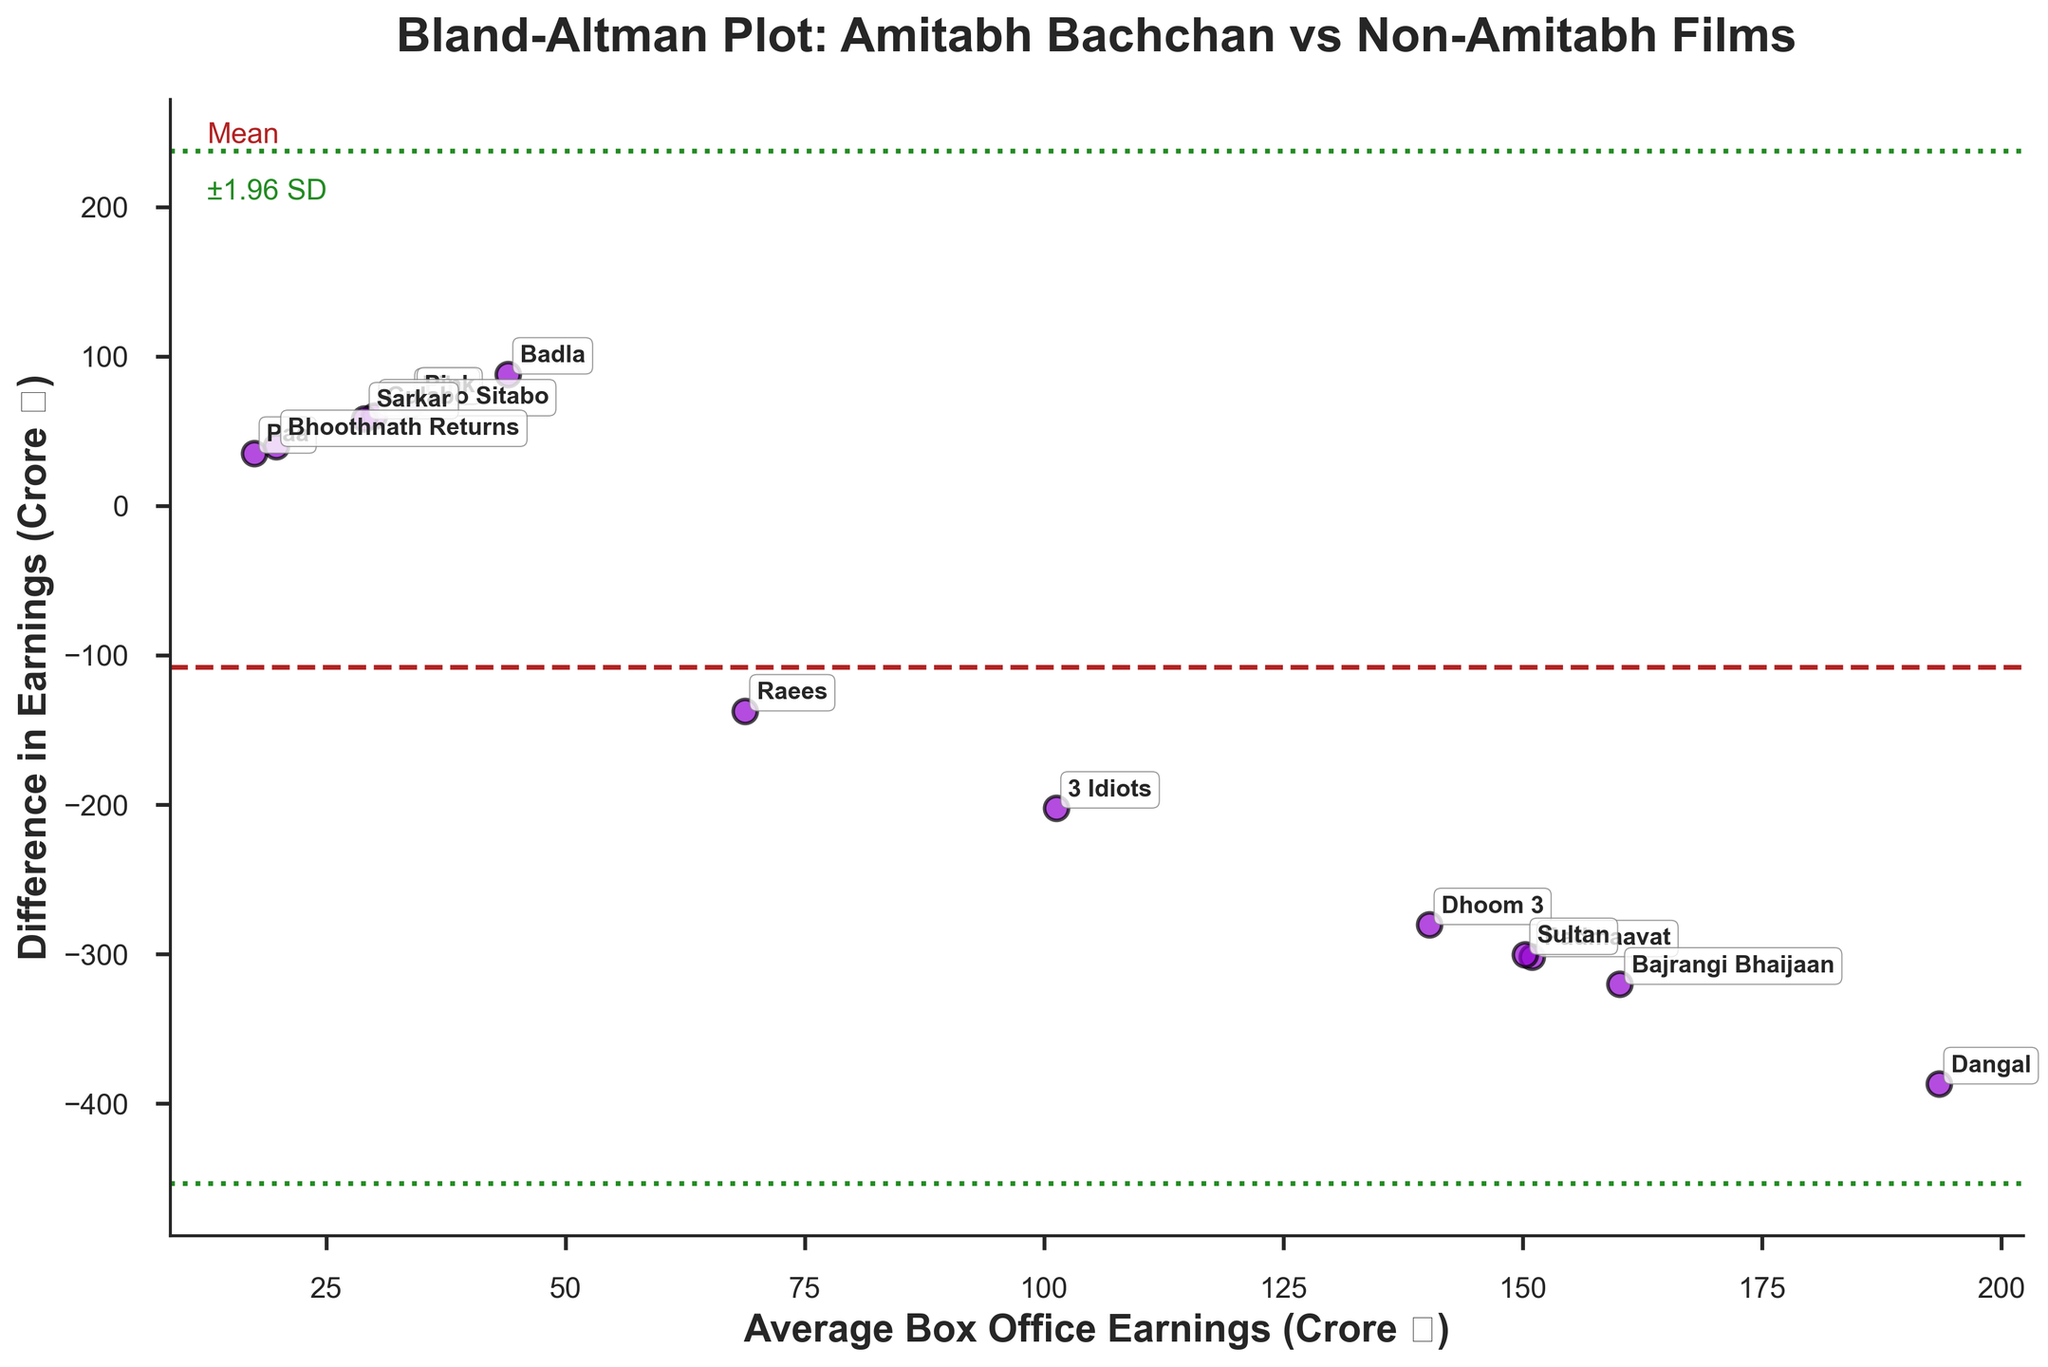What is the title of the plot? The title is displayed at the top of the plot and reads 'Bland-Altman Plot: Amitabh Bachchan vs Non-Amitabh Films'.
Answer: Bland-Altman Plot: Amitabh Bachchan vs Non-Amitabh Films What are the x and y axes labels? The x-axis label is 'Average Box Office Earnings (Crore ₹)' and the y-axis label is 'Difference in Earnings (Crore ₹)'. Both labels are written in bold.
Answer: Average Box Office Earnings (Crore ₹), Difference in Earnings (Crore ₹) How many data points are there in the plot? Each movie represents a data point, and there are 14 movies listed in the data. Thus, there are 14 data points in the plot.
Answer: 14 Which movie has the highest average box office earnings? Checking the 'Average' column, 'Dangal' has the highest value with an average of 193.5 Crore ₹.
Answer: Dangal Which movie has the largest difference in earnings? The 'Difference' column indicates the disparity between earnings, and 'Dangal' shows the largest difference with a value of -387.0 Crore ₹.
Answer: Dangal Describe the colors used for the mean and ±1.96 SD lines. The mean line is displayed in a dashed 'firebrick' color, and the ±1.96 SD lines are shown in a dotted 'forestgreen' color.
Answer: firebrick for mean, forestgreen for ±1.96 SD What is the value at which the mean difference line is drawn? The mean difference appears where the dashed 'firebrick' line intersects the y-axis, and it is calculated to be -107.71 Crore ₹.
Answer: -107.71 Crore ₹ Between which two movies is the smallest difference in earnings observed? By comparing the 'Difference' values visually, 'Piku' and 'Pink' both have the smallest difference in earnings, which are 67.5 Crore ₹ and 68.0 Crore ₹ respectively.
Answer: Piku and Pink Which movies have earnings differences above 100 Crore ₹? To find movies with earnings differences above 100 Crore ₹, we identify 'Dhoom 3', '3 Idiots', 'Dangal', 'Padmaavat', 'Sultan', and 'Bajrangi Bhaijaan' with negative values greater than 100 Crore ₹.
Answer: Dhoom 3, 3 Idiots, Dangal, Padmaavat, Sultan, Bajrangi Bhaijaan Are Amitabh Bachchan films generally earning more or less compared to non-Amitabh films? Most data points (negative differences) show non-Amitabh films earning more since the difference (Amitabh earnings - Non-Amitabh earnings) is predominantly negative.
Answer: Less 